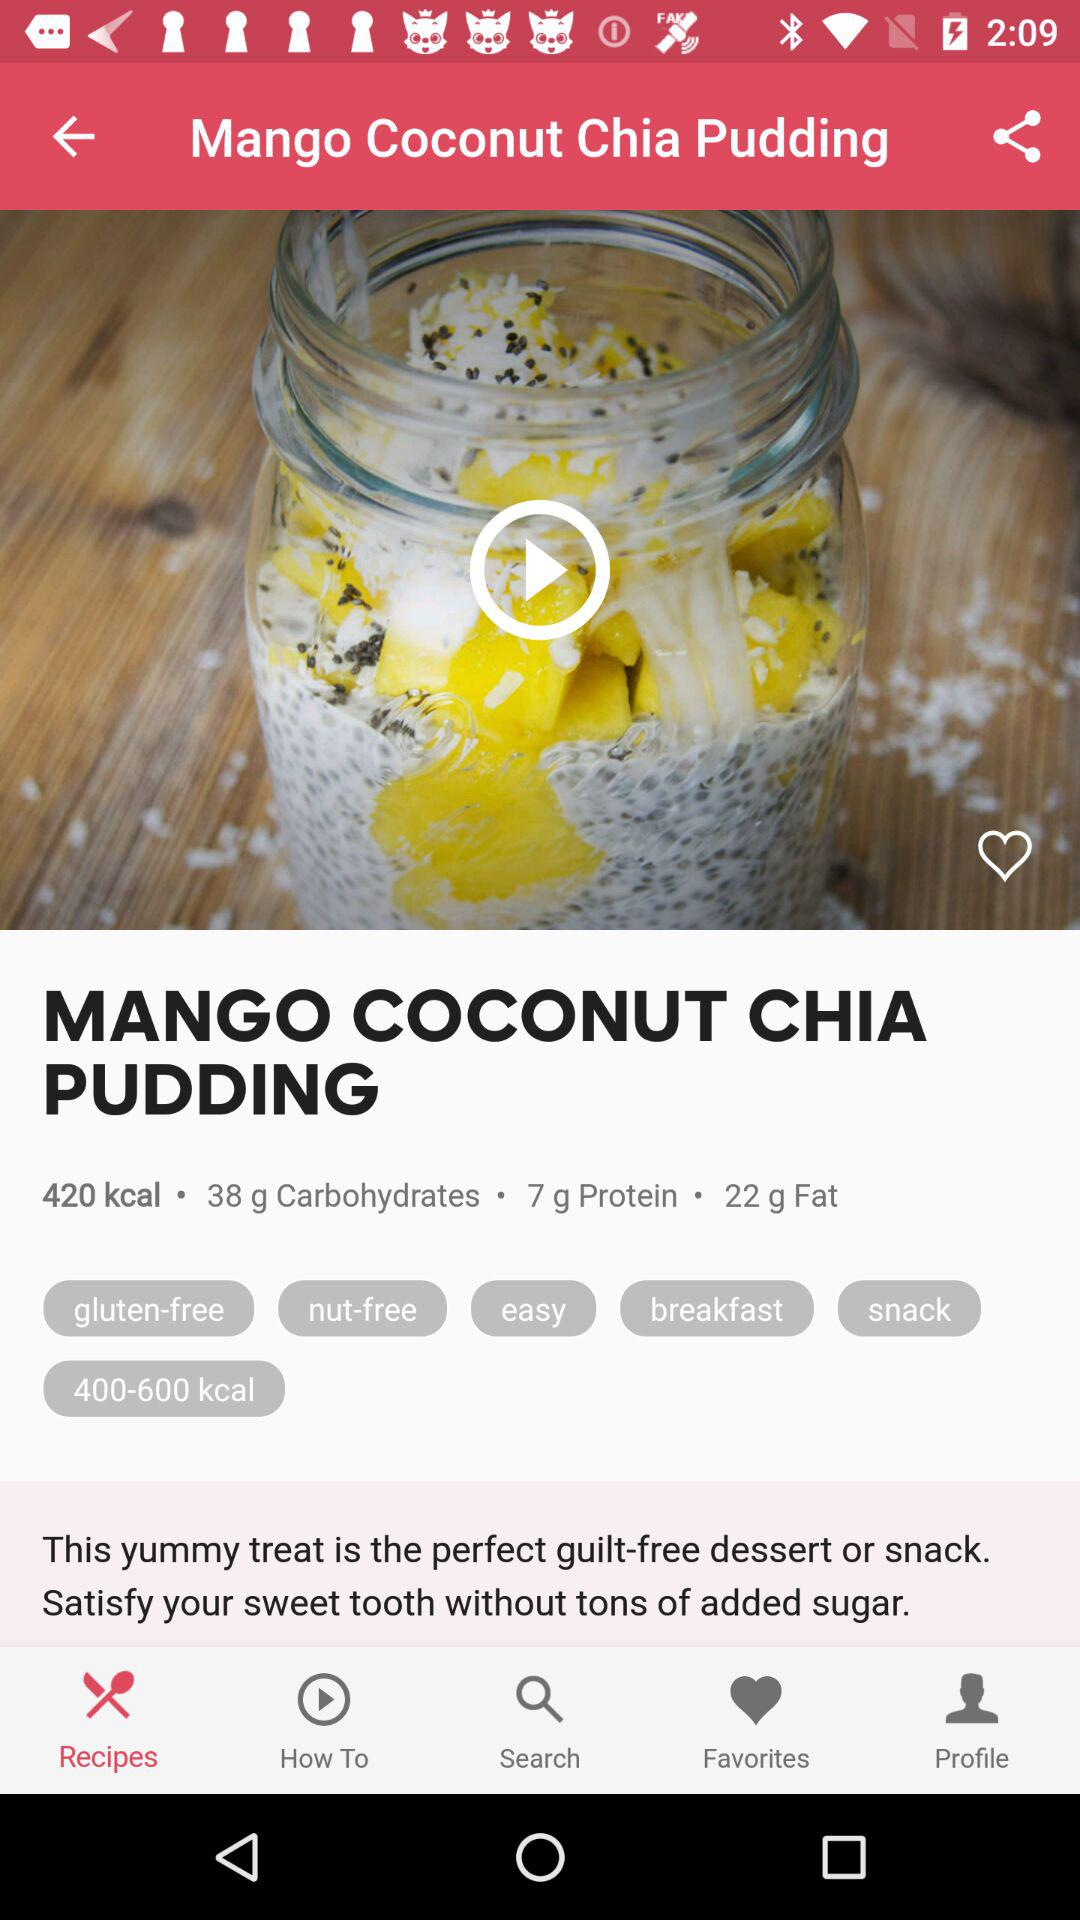How many calories are in this recipe?
Answer the question using a single word or phrase. 420 kcal 